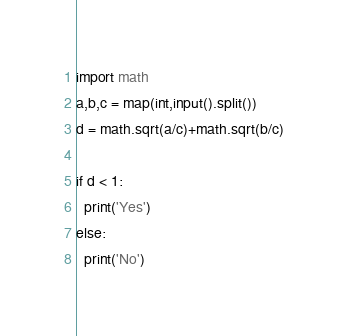<code> <loc_0><loc_0><loc_500><loc_500><_Python_>import math
a,b,c = map(int,input().split())
d = math.sqrt(a/c)+math.sqrt(b/c)

if d < 1:
  print('Yes')
else:
  print('No')
</code> 